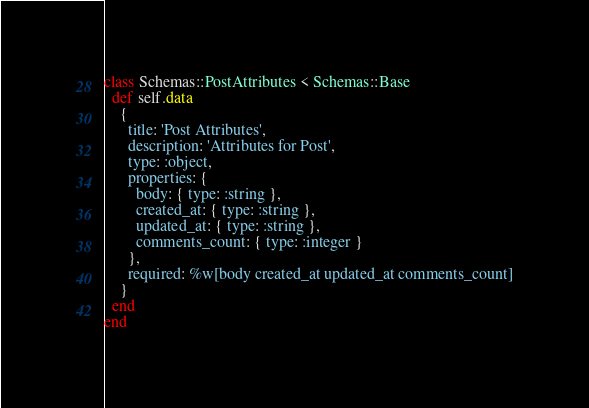<code> <loc_0><loc_0><loc_500><loc_500><_Ruby_>class Schemas::PostAttributes < Schemas::Base
  def self.data
    {
      title: 'Post Attributes',
      description: 'Attributes for Post',
      type: :object,
      properties: {
        body: { type: :string },
        created_at: { type: :string },
        updated_at: { type: :string },
        comments_count: { type: :integer }
      },
      required: %w[body created_at updated_at comments_count]
    }
  end
end
</code> 